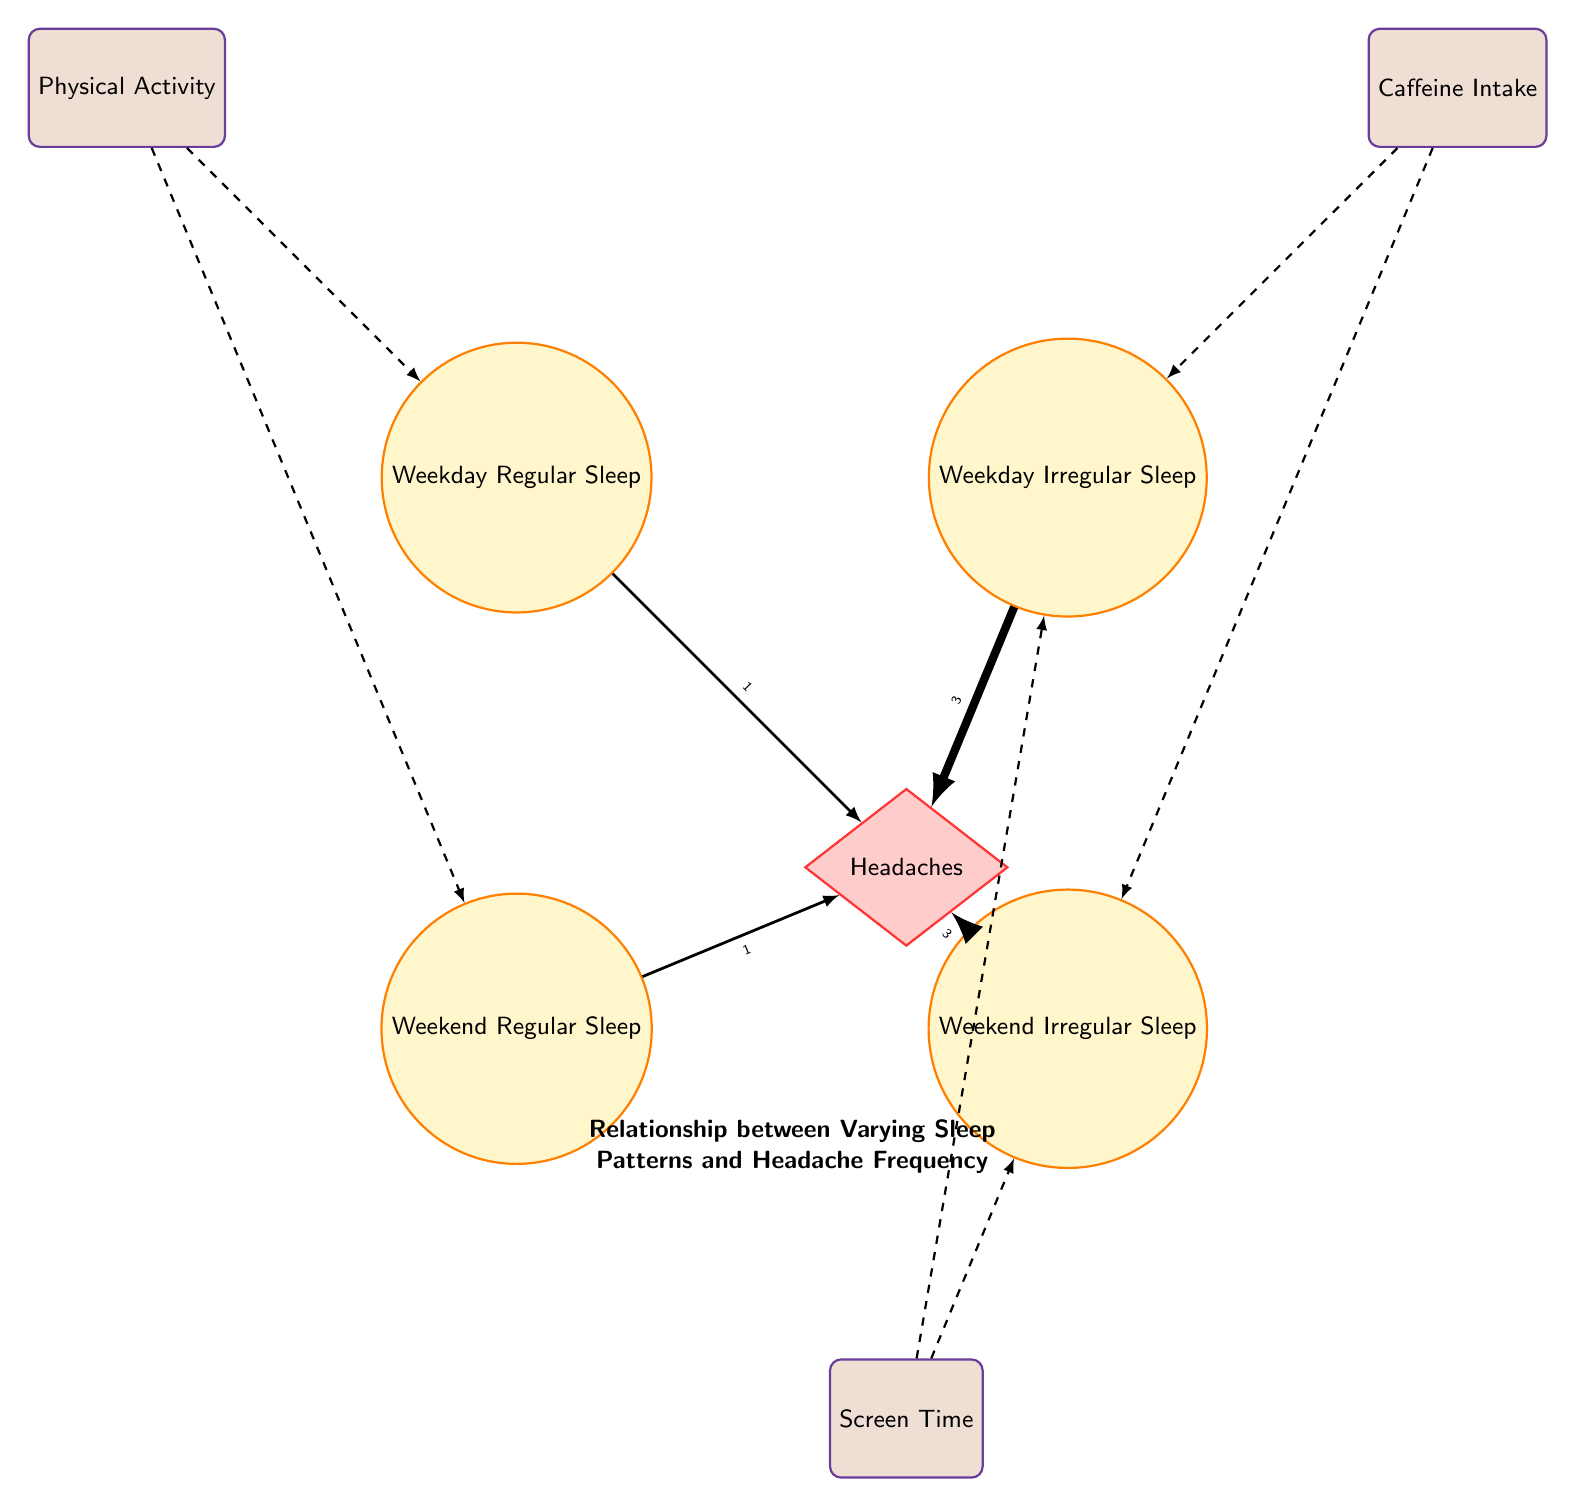What is the link value between Weekday Irregular Sleep and Headaches? The diagram shows an arrow connecting Weekday Irregular Sleep to Headaches with a value of 3, indicating that headaches are most frequently associated with this type of sleep pattern.
Answer: 3 How many factors are linked to sleep patterns in the diagram? By examining the nodes with dashed connections, we can identify three factors: Physical Activity, Caffeine Intake, and Screen Time. Each of these factors influences the sleep patterns represented in the diagram.
Answer: 3 Which type of sleep pattern has the highest link value to headaches? Comparing the link values from all sleep patterns to Headaches, both Weekend Irregular Sleep and Weekday Irregular Sleep have a value of 3, which is higher than the other sleep patterns.
Answer: Weekend Irregular Sleep and Weekday Irregular Sleep What is the total number of nodes in the diagram? Counting the distinct nodes shown, we have: Weekday Regular Sleep, Weekday Irregular Sleep, Weekend Regular Sleep, Weekend Irregular Sleep, Headaches, Physical Activity, Caffeine Intake, and Screen Time, resulting in a total of 8 nodes.
Answer: 8 What type of sleep is least associated with headaches based on the diagram? The analysis of the links to Headaches shows that both Weekday Regular Sleep and Weekend Regular Sleep have the lowest link values of 1, indicating that they are least associated with headaches.
Answer: Weekday Regular Sleep and Weekend Regular Sleep What is the connection between Physical Activity and sleep patterns? The diagram shows dashed lines linking Physical Activity to both Weekday Regular Sleep and Weekend Regular Sleep, demonstrating that Physical Activity positively influences regular sleep patterns.
Answer: Positive influence How does Caffeine Intake affect sleep patterns? The diagram illustrates that Caffeine Intake connects with both Weekday Irregular Sleep and Weekend Irregular Sleep, indicating a potential increase in irregular sleep due to caffeine consumption.
Answer: Increases irregular sleep Which sleep pattern is connected to the highest number of headache occurrences? Weekday Irregular Sleep and Weekend Irregular Sleep both have the highest values of 3 linked to Headaches, indicating these patterns are associated with more frequent headache occurrences.
Answer: Weekday Irregular Sleep and Weekend Irregular Sleep What are the two types of weekend sleep patterns represented in the diagram? The diagram categorizes two types of weekend sleep patterns: Regular Sleep and Irregular Sleep, which are directly listed as nodes in the diagram.
Answer: Regular Sleep and Irregular Sleep 